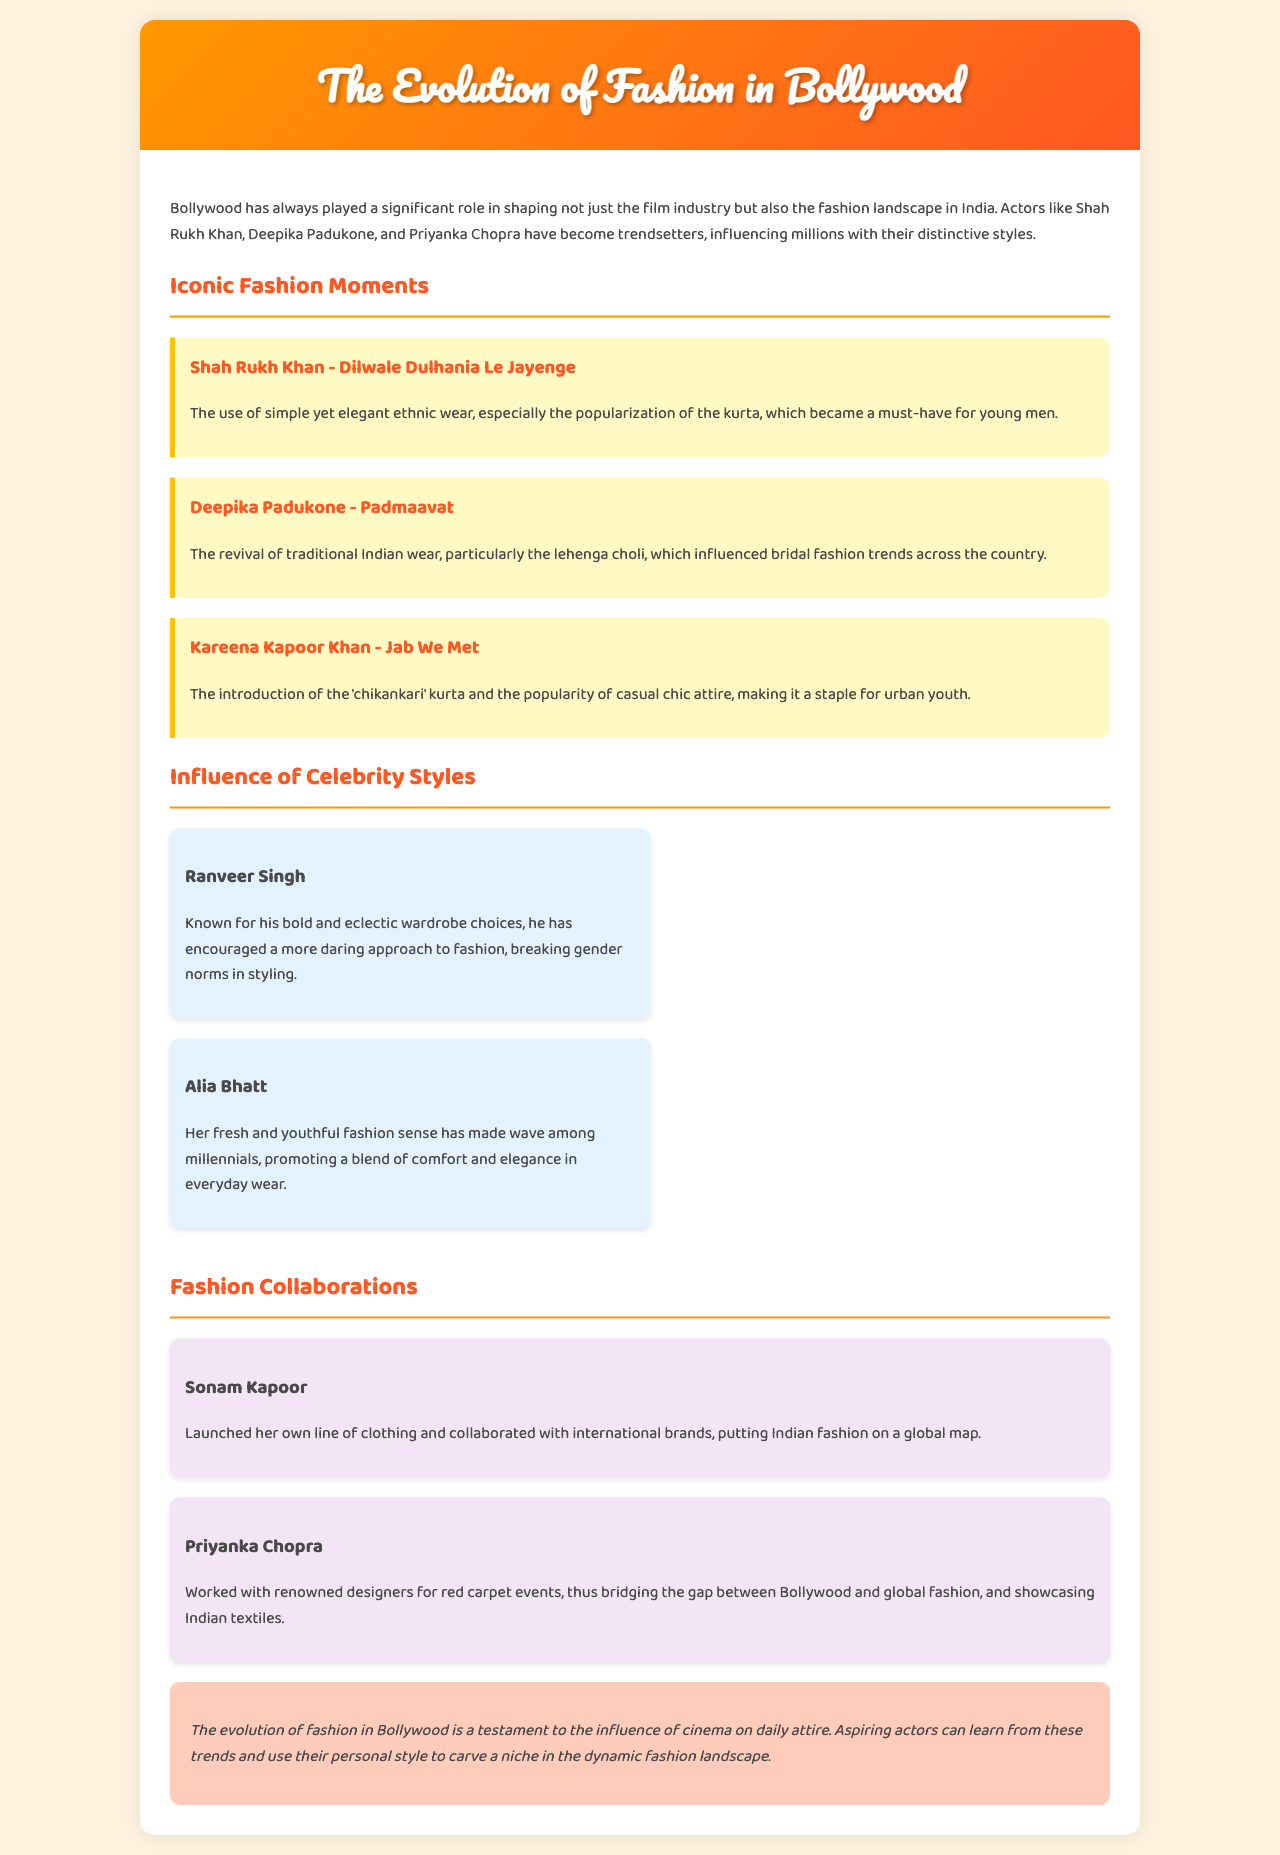What is the title of the report? The title is indicated in the header of the document, which states the focus of the report on fashion in Bollywood.
Answer: The Evolution of Fashion in Bollywood Who is mentioned for popularizing the kurta? Shah Rukh Khan is identified in the document for his iconic fashion moment that involves ethnic wear, particularly the kurta.
Answer: Shah Rukh Khan What style did Deepika Padukone influence? The report details a significant fashion impact made by Deepika Padukone related to traditional Indian wear, especially a certain outfit type.
Answer: Lehenga choli Which actor is known for bold wardrobe choices? The document highlights Ranveer Singh as the celebrity recognized for his daring approach to fashion.
Answer: Ranveer Singh How has Alia Bhatt's style been described? Alia Bhatt's fashion sense is described in the context of her appeal and influence on a specific demographic.
Answer: Fresh and youthful What specific clothing line did Sonam Kapoor launch? The document mentions that Sonam Kapoor initiated her own clothing line, showcasing her contribution to fashion.
Answer: Clothing line How many iconic fashion moments are described in the report? The report lists distinct fashion moments tied to three different actors, showing their contribution to fashion evolution.
Answer: Three What is the main conclusion about Bollywood fashion's evolution? The concluding statement summarizes the overall influence of cinema on daily attire for individuals aspiring to enter the industry.
Answer: Influence of cinema 